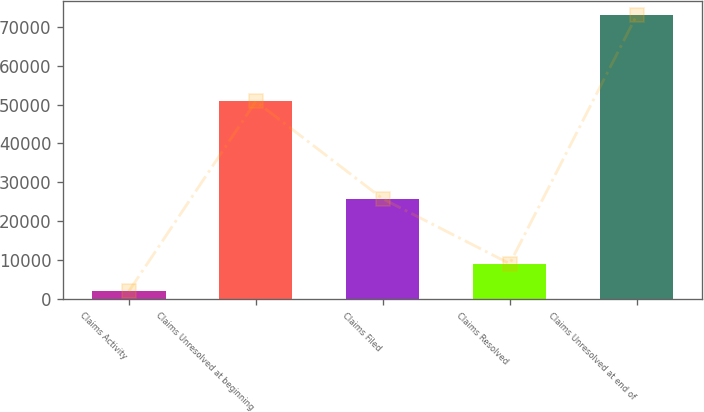<chart> <loc_0><loc_0><loc_500><loc_500><bar_chart><fcel>Claims Activity<fcel>Claims Unresolved at beginning<fcel>Claims Filed<fcel>Claims Resolved<fcel>Claims Unresolved at end of<nl><fcel>2003<fcel>50821<fcel>25765<fcel>9100.3<fcel>72976<nl></chart> 